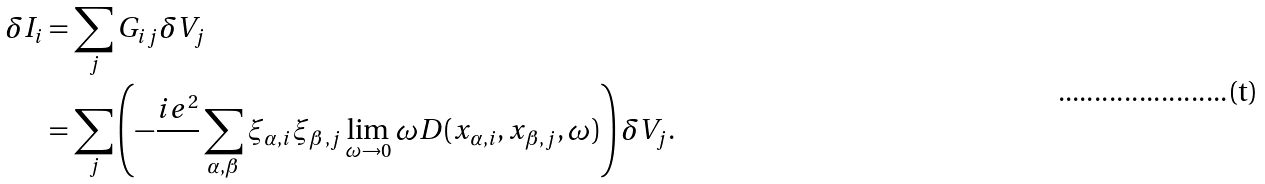Convert formula to latex. <formula><loc_0><loc_0><loc_500><loc_500>\delta I _ { i } & = \sum _ { j } G _ { i j } \delta V _ { j } \\ & = \sum _ { j } \left ( - \frac { i e ^ { 2 } } { } \sum _ { \alpha , \beta } \xi _ { \alpha , i } \xi _ { \beta , j } \lim _ { \omega \to 0 } \omega D ( x _ { \alpha , i } , x _ { \beta , j } , \omega ) \right ) \delta V _ { j } .</formula> 